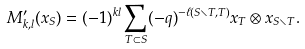<formula> <loc_0><loc_0><loc_500><loc_500>M ^ { \prime } _ { k , l } ( x _ { S } ) = ( - 1 ) ^ { k l } \sum _ { T \subset S } ( - q ) ^ { - \ell ( S \smallsetminus T , T ) } x _ { T } \otimes x _ { S \smallsetminus T } .</formula> 